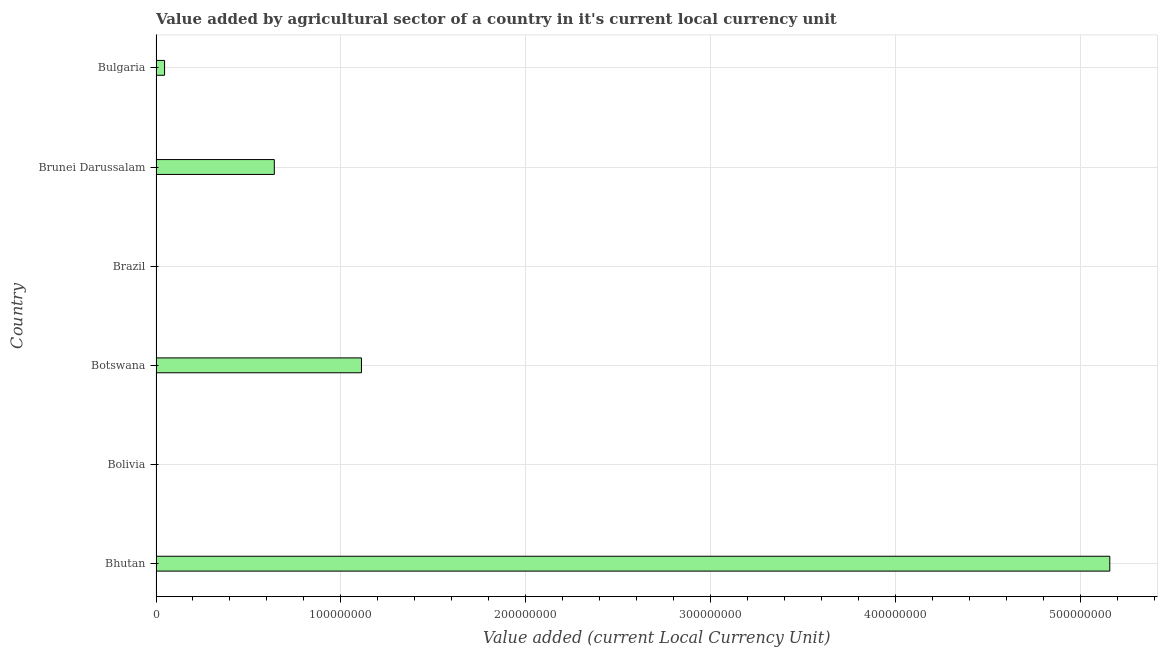Does the graph contain grids?
Give a very brief answer. Yes. What is the title of the graph?
Offer a very short reply. Value added by agricultural sector of a country in it's current local currency unit. What is the label or title of the X-axis?
Your answer should be very brief. Value added (current Local Currency Unit). What is the label or title of the Y-axis?
Offer a very short reply. Country. What is the value added by agriculture sector in Bulgaria?
Your answer should be very brief. 4.62e+06. Across all countries, what is the maximum value added by agriculture sector?
Ensure brevity in your answer.  5.16e+08. Across all countries, what is the minimum value added by agriculture sector?
Give a very brief answer. 0.86. In which country was the value added by agriculture sector maximum?
Your answer should be compact. Bhutan. In which country was the value added by agriculture sector minimum?
Keep it short and to the point. Brazil. What is the sum of the value added by agriculture sector?
Make the answer very short. 6.96e+08. What is the difference between the value added by agriculture sector in Botswana and Brunei Darussalam?
Offer a terse response. 4.72e+07. What is the average value added by agriculture sector per country?
Offer a terse response. 1.16e+08. What is the median value added by agriculture sector?
Give a very brief answer. 3.43e+07. What is the ratio of the value added by agriculture sector in Bolivia to that in Botswana?
Provide a short and direct response. 0. Is the value added by agriculture sector in Brunei Darussalam less than that in Bulgaria?
Ensure brevity in your answer.  No. What is the difference between the highest and the second highest value added by agriculture sector?
Give a very brief answer. 4.05e+08. What is the difference between the highest and the lowest value added by agriculture sector?
Your response must be concise. 5.16e+08. In how many countries, is the value added by agriculture sector greater than the average value added by agriculture sector taken over all countries?
Offer a very short reply. 1. How many bars are there?
Ensure brevity in your answer.  6. How many countries are there in the graph?
Ensure brevity in your answer.  6. What is the difference between two consecutive major ticks on the X-axis?
Offer a terse response. 1.00e+08. Are the values on the major ticks of X-axis written in scientific E-notation?
Offer a very short reply. No. What is the Value added (current Local Currency Unit) in Bhutan?
Keep it short and to the point. 5.16e+08. What is the Value added (current Local Currency Unit) in Bolivia?
Your answer should be very brief. 2.50e+04. What is the Value added (current Local Currency Unit) in Botswana?
Provide a short and direct response. 1.11e+08. What is the Value added (current Local Currency Unit) in Brazil?
Give a very brief answer. 0.86. What is the Value added (current Local Currency Unit) in Brunei Darussalam?
Offer a terse response. 6.40e+07. What is the Value added (current Local Currency Unit) of Bulgaria?
Provide a succinct answer. 4.62e+06. What is the difference between the Value added (current Local Currency Unit) in Bhutan and Bolivia?
Give a very brief answer. 5.16e+08. What is the difference between the Value added (current Local Currency Unit) in Bhutan and Botswana?
Your response must be concise. 4.05e+08. What is the difference between the Value added (current Local Currency Unit) in Bhutan and Brazil?
Keep it short and to the point. 5.16e+08. What is the difference between the Value added (current Local Currency Unit) in Bhutan and Brunei Darussalam?
Offer a very short reply. 4.52e+08. What is the difference between the Value added (current Local Currency Unit) in Bhutan and Bulgaria?
Ensure brevity in your answer.  5.11e+08. What is the difference between the Value added (current Local Currency Unit) in Bolivia and Botswana?
Give a very brief answer. -1.11e+08. What is the difference between the Value added (current Local Currency Unit) in Bolivia and Brazil?
Provide a succinct answer. 2.50e+04. What is the difference between the Value added (current Local Currency Unit) in Bolivia and Brunei Darussalam?
Keep it short and to the point. -6.40e+07. What is the difference between the Value added (current Local Currency Unit) in Bolivia and Bulgaria?
Your answer should be very brief. -4.60e+06. What is the difference between the Value added (current Local Currency Unit) in Botswana and Brazil?
Provide a short and direct response. 1.11e+08. What is the difference between the Value added (current Local Currency Unit) in Botswana and Brunei Darussalam?
Provide a succinct answer. 4.72e+07. What is the difference between the Value added (current Local Currency Unit) in Botswana and Bulgaria?
Make the answer very short. 1.07e+08. What is the difference between the Value added (current Local Currency Unit) in Brazil and Brunei Darussalam?
Your answer should be compact. -6.40e+07. What is the difference between the Value added (current Local Currency Unit) in Brazil and Bulgaria?
Offer a very short reply. -4.62e+06. What is the difference between the Value added (current Local Currency Unit) in Brunei Darussalam and Bulgaria?
Provide a short and direct response. 5.94e+07. What is the ratio of the Value added (current Local Currency Unit) in Bhutan to that in Bolivia?
Ensure brevity in your answer.  2.07e+04. What is the ratio of the Value added (current Local Currency Unit) in Bhutan to that in Botswana?
Keep it short and to the point. 4.64. What is the ratio of the Value added (current Local Currency Unit) in Bhutan to that in Brazil?
Offer a terse response. 6.00e+08. What is the ratio of the Value added (current Local Currency Unit) in Bhutan to that in Brunei Darussalam?
Offer a very short reply. 8.06. What is the ratio of the Value added (current Local Currency Unit) in Bhutan to that in Bulgaria?
Offer a very short reply. 111.58. What is the ratio of the Value added (current Local Currency Unit) in Bolivia to that in Botswana?
Offer a very short reply. 0. What is the ratio of the Value added (current Local Currency Unit) in Bolivia to that in Brazil?
Offer a very short reply. 2.90e+04. What is the ratio of the Value added (current Local Currency Unit) in Bolivia to that in Bulgaria?
Offer a terse response. 0.01. What is the ratio of the Value added (current Local Currency Unit) in Botswana to that in Brazil?
Your answer should be compact. 1.29e+08. What is the ratio of the Value added (current Local Currency Unit) in Botswana to that in Brunei Darussalam?
Make the answer very short. 1.74. What is the ratio of the Value added (current Local Currency Unit) in Botswana to that in Bulgaria?
Offer a terse response. 24.03. What is the ratio of the Value added (current Local Currency Unit) in Brazil to that in Brunei Darussalam?
Give a very brief answer. 0. What is the ratio of the Value added (current Local Currency Unit) in Brunei Darussalam to that in Bulgaria?
Offer a terse response. 13.84. 